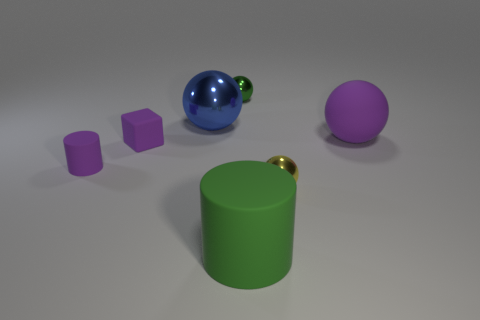Add 1 small yellow metallic balls. How many objects exist? 8 Subtract all shiny balls. How many balls are left? 1 Subtract 1 balls. How many balls are left? 3 Subtract all yellow balls. How many balls are left? 3 Subtract all cylinders. How many objects are left? 5 Subtract all tiny purple cubes. Subtract all blue metal spheres. How many objects are left? 5 Add 5 big blue things. How many big blue things are left? 6 Add 3 red rubber spheres. How many red rubber spheres exist? 3 Subtract 0 red blocks. How many objects are left? 7 Subtract all yellow spheres. Subtract all cyan cylinders. How many spheres are left? 3 